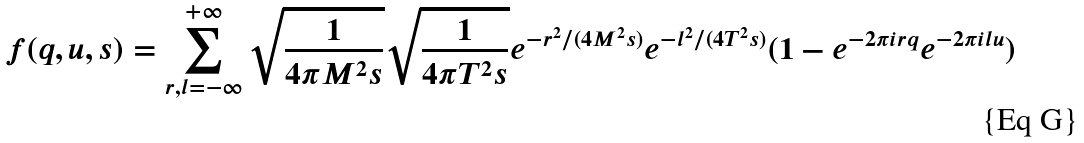Convert formula to latex. <formula><loc_0><loc_0><loc_500><loc_500>f ( q , u , s ) = \sum _ { r , l = - \infty } ^ { + \infty } \sqrt { \frac { 1 } { 4 \pi M ^ { 2 } s } } \sqrt { \frac { 1 } { 4 \pi T ^ { 2 } s } } e ^ { - r ^ { 2 } / ( 4 M ^ { 2 } s ) } e ^ { - l ^ { 2 } / ( 4 T ^ { 2 } s ) } ( 1 - e ^ { - 2 \pi i r q } e ^ { - 2 \pi i l u } )</formula> 